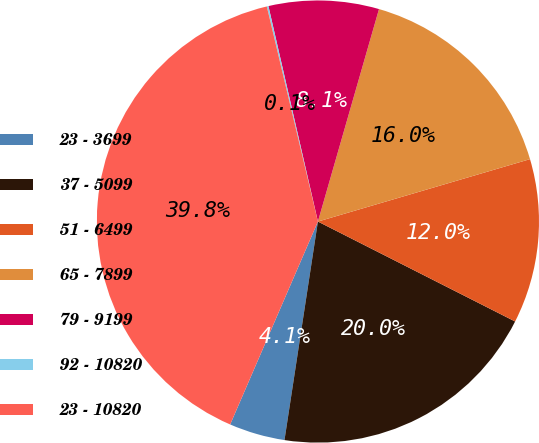Convert chart to OTSL. <chart><loc_0><loc_0><loc_500><loc_500><pie_chart><fcel>23 - 3699<fcel>37 - 5099<fcel>51 - 6499<fcel>65 - 7899<fcel>79 - 9199<fcel>92 - 10820<fcel>23 - 10820<nl><fcel>4.08%<fcel>19.95%<fcel>12.02%<fcel>15.99%<fcel>8.05%<fcel>0.12%<fcel>39.79%<nl></chart> 